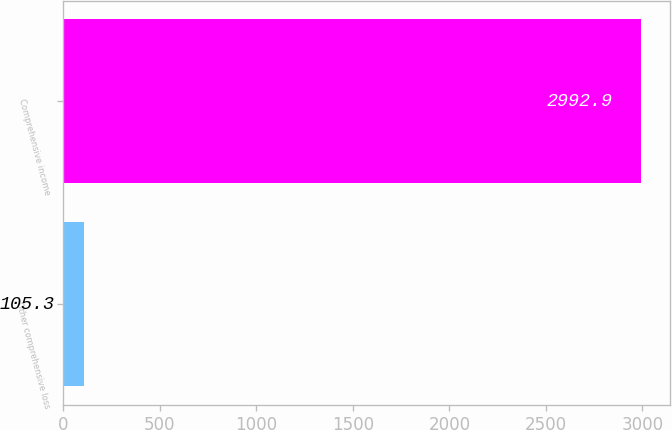Convert chart. <chart><loc_0><loc_0><loc_500><loc_500><bar_chart><fcel>Other comprehensive loss<fcel>Comprehensive income<nl><fcel>105.3<fcel>2992.9<nl></chart> 